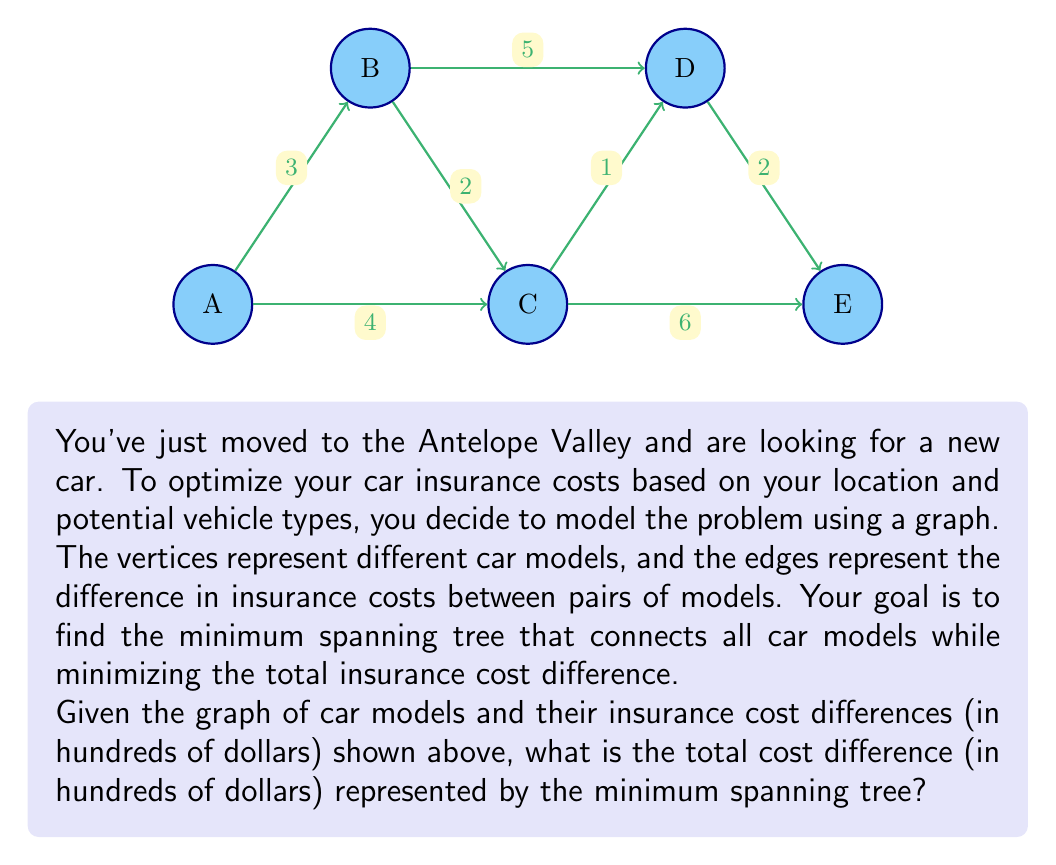What is the answer to this math problem? To find the minimum spanning tree, we'll use Kruskal's algorithm:

1) Sort all edges by weight (cost difference) in ascending order:
   $$(C,D): 1, (B,C): 2, (D,E): 2, (A,B): 3, (A,C): 4, (B,D): 5, (C,E): 6$$

2) Start with an empty set of edges and add edges one by one, skipping those that would create a cycle:

   a) Add $(C,D): 1$ - Connects C and D
   b) Add $(B,C): 2$ - Connects B to C (and D)
   c) Add $(D,E): 2$ - Connects E to the existing tree
   d) Add $(A,B): 3$ - Connects A to the existing tree

3) At this point, all vertices are connected, so we stop.

4) The minimum spanning tree consists of the edges:
   $$(C,D), (B,C), (D,E), (A,B)$$

5) Calculate the total cost difference:
   $$1 + 2 + 2 + 3 = 8$$

Therefore, the total cost difference represented by the minimum spanning tree is 8 hundred dollars, or $800.
Answer: $800 